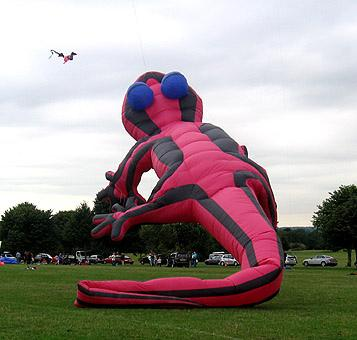What reptile is depicted in the extra large kite?

Choices:
A) chameleon
B) iguana
C) tortoise
D) lizard chameleon 